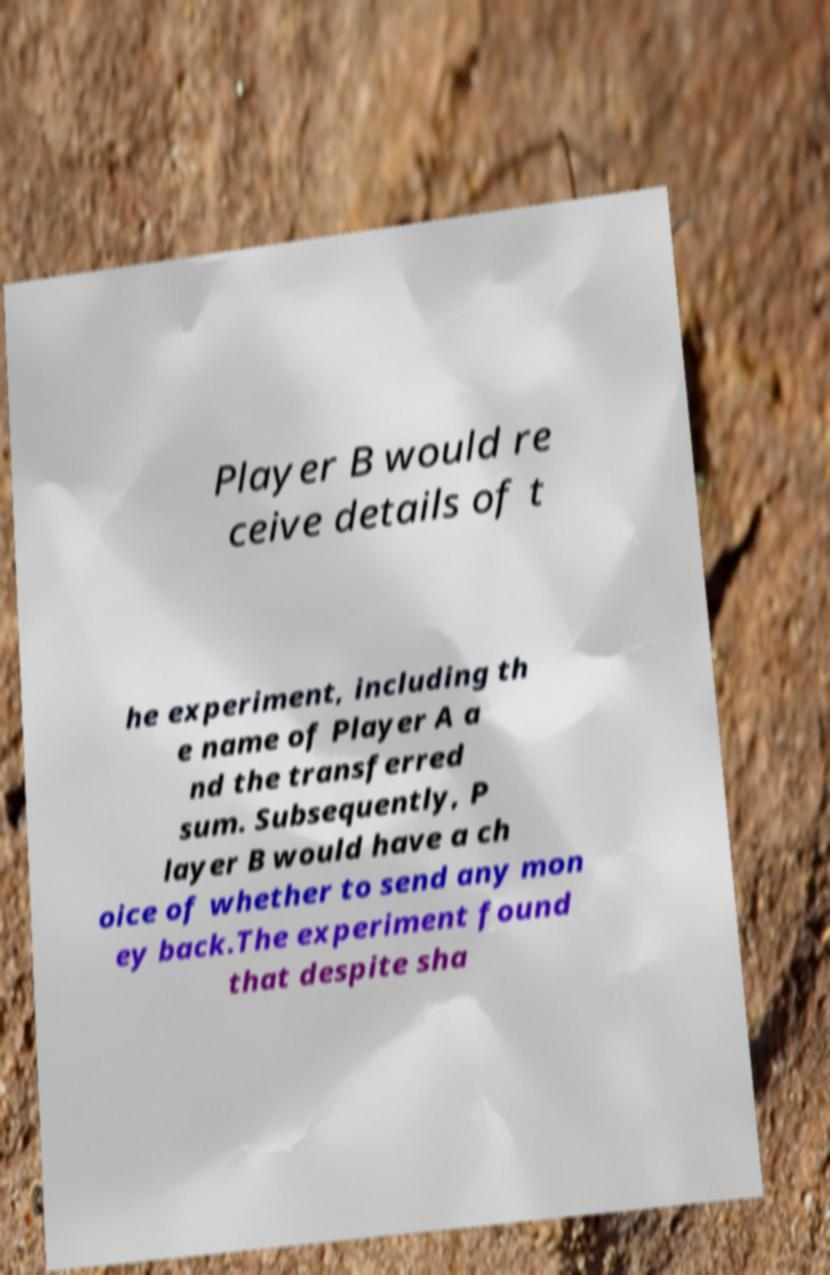Can you accurately transcribe the text from the provided image for me? Player B would re ceive details of t he experiment, including th e name of Player A a nd the transferred sum. Subsequently, P layer B would have a ch oice of whether to send any mon ey back.The experiment found that despite sha 